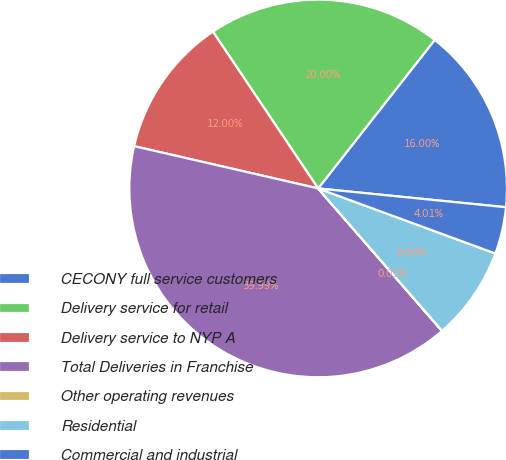<chart> <loc_0><loc_0><loc_500><loc_500><pie_chart><fcel>CECONY full service customers<fcel>Delivery service for retail<fcel>Delivery service to NYP A<fcel>Total Deliveries in Franchise<fcel>Other operating revenues<fcel>Residential<fcel>Commercial and industrial<nl><fcel>16.0%<fcel>20.0%<fcel>12.0%<fcel>39.99%<fcel>0.01%<fcel>8.0%<fcel>4.01%<nl></chart> 